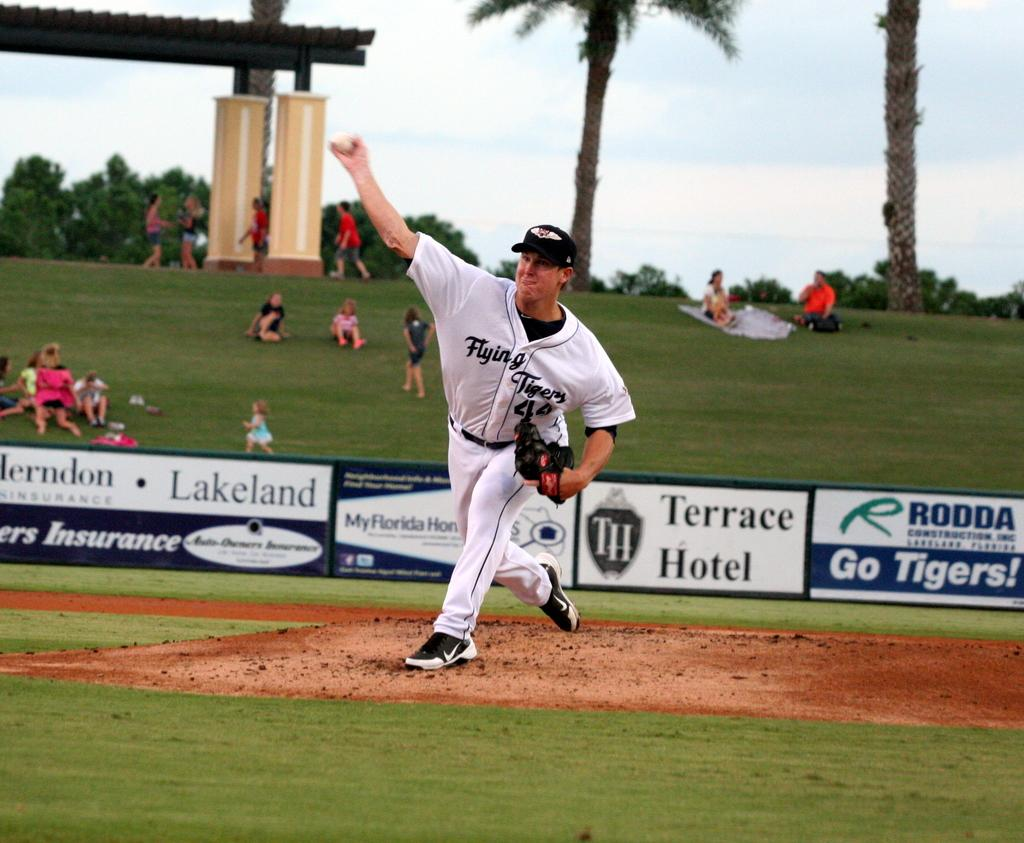<image>
Relay a brief, clear account of the picture shown. The player in the white uniform who is pitching the ball plays for the Flying Tigers. 